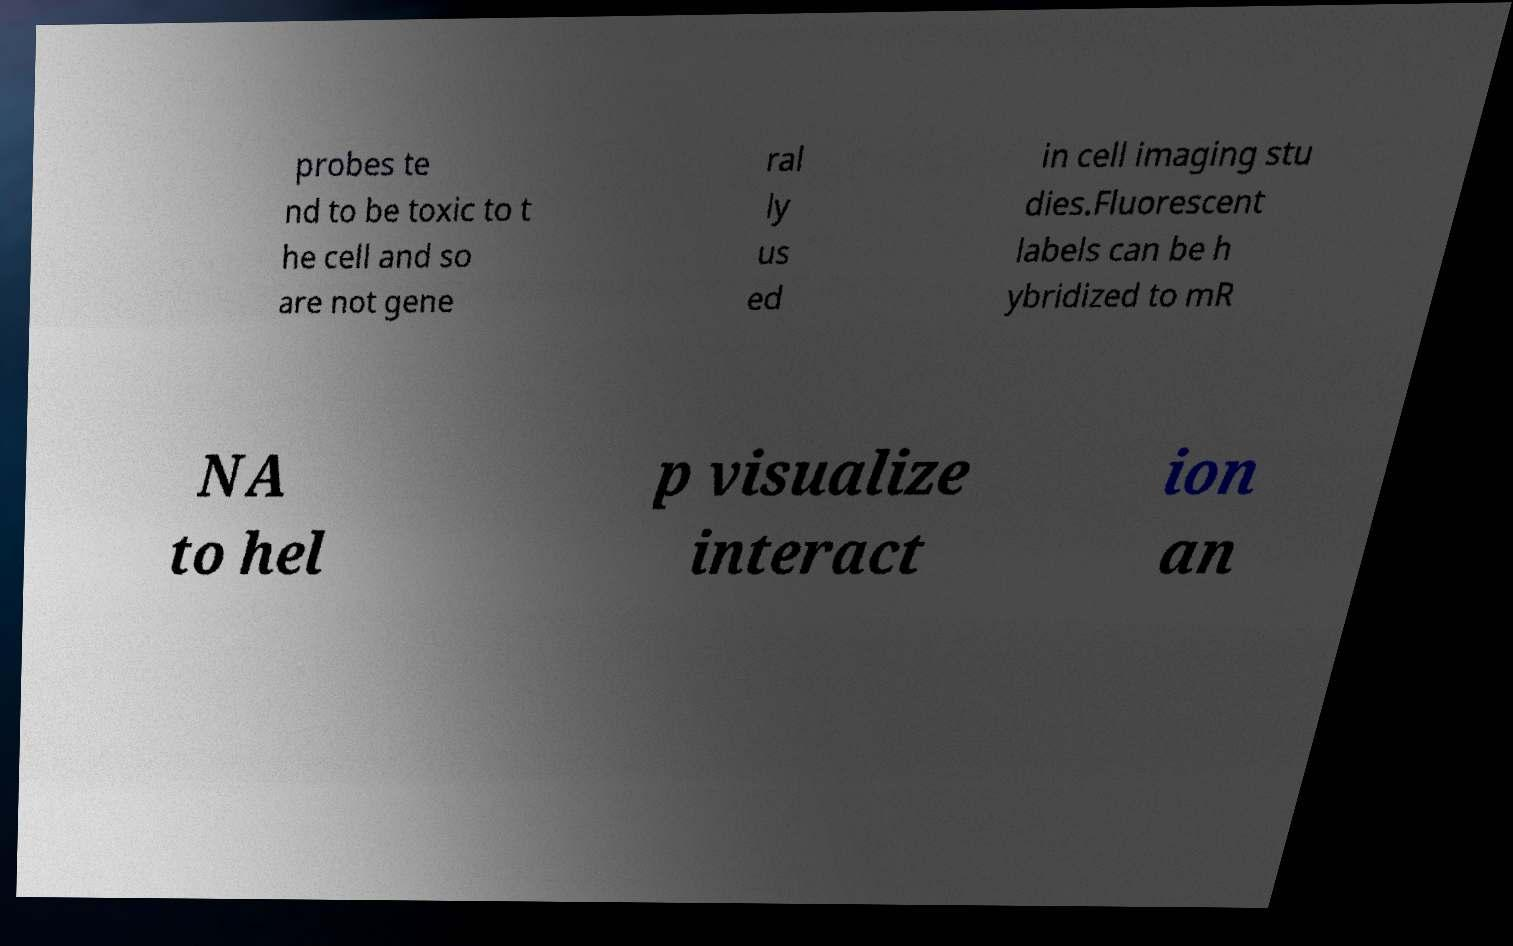For documentation purposes, I need the text within this image transcribed. Could you provide that? probes te nd to be toxic to t he cell and so are not gene ral ly us ed in cell imaging stu dies.Fluorescent labels can be h ybridized to mR NA to hel p visualize interact ion an 